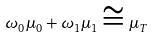<formula> <loc_0><loc_0><loc_500><loc_500>\omega _ { 0 } \mu _ { 0 } + \omega _ { 1 } \mu _ { 1 } \cong \mu _ { T }</formula> 